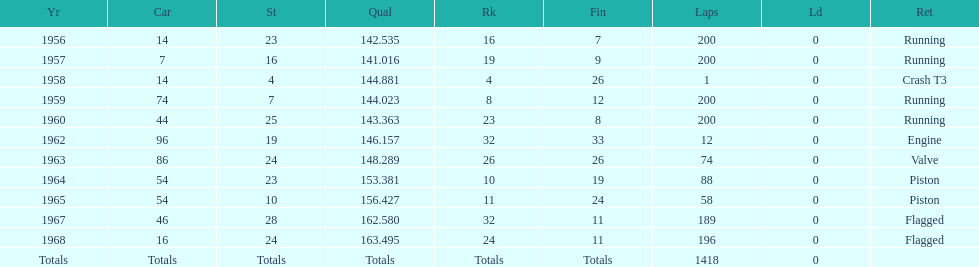How often did bob veith achieve a ranking better than 10th in the indy 500? 2. 